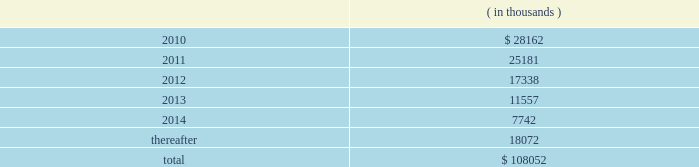There were no changes in the company 2019s valuation techniques used to measure fair values on a recurring basis as a result of adopting asc 820 .
Pca had no assets or liabilities that were measured on a nonrecurring basis .
11 .
Stockholders 2019 equity on october 17 , 2007 , pca announced that its board of directors authorized a $ 150.0 million common stock repurchase program .
There is no expiration date for the common stock repurchase program .
Through december 31 , 2008 , the company repurchased 3818729 shares of common stock , with 3142600 shares repurchased during 2008 and 676129 shares repurchased during 2007 .
All repurchased shares were retired prior to december 31 , 2008 .
There were no shares repurchased in 2009 .
As of december 31 , 2009 , $ 65.0 million of the $ 150.0 million authorization remained available for repurchase of the company 2019s common stock .
12 .
Commitments and contingencies capital commitments the company had authorized capital commitments of approximately $ 41.7 million and $ 43.0 million as of december 31 , 2009 and 2008 , respectively , in connection with the expansion and replacement of existing facilities and equipment .
In addition , commitments at december 31 , 2009 for the major energy optimization projects at its counce and valdosta mills totaled $ 156.3 million .
Lease obligations pca leases space for certain of its facilities and cutting rights to approximately 91000 acres of timberland under long-term leases .
The company also leases equipment , primarily vehicles and rolling stock , and other assets under long-term leases with a duration of two to seven years .
The minimum lease payments under non-cancelable operating leases with lease terms in excess of one year are as follows: .
Total lease expense , including base rent on all leases and executory costs , such as insurance , taxes , and maintenance , for the years ended december 31 , 2009 , 2008 and 2007 was $ 41.3 million , $ 41.6 million and $ 39.8 million , respectively .
These costs are included in cost of goods sold and selling and administrative expenses .
Pca was obligated under capital leases covering buildings and machinery and equipment in the amount of $ 23.1 million and $ 23.7 million at december 31 , 2009 and 2008 , respectively .
During the fourth quarter of 2008 , the company entered into a capital lease relating to buildings and machinery , totaling $ 23.9 million , payable over 20 years .
This capital lease amount is a non-cash transaction and , accordingly , has been excluded packaging corporation of america notes to consolidated financial statements ( continued ) december 31 , 2009 .
As of december 31 , 2009 , what percentage of the $ 150.0 million authorization remained available for repurchase of the company 2019s common stock? 
Computations: (65.0 / 150.0)
Answer: 0.43333. 